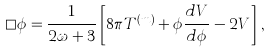<formula> <loc_0><loc_0><loc_500><loc_500>\square \phi = \frac { 1 } { 2 \omega + 3 } \left [ 8 \pi T ^ { ( m ) } + \phi \frac { d V } { d \phi } - 2 V \right ] \, ,</formula> 